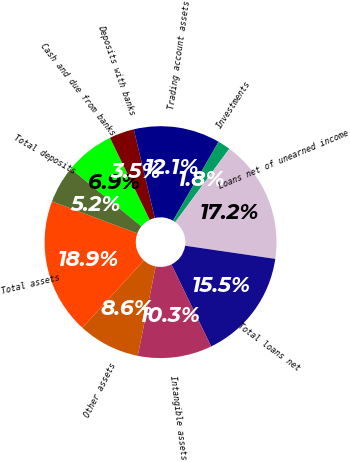Convert chart. <chart><loc_0><loc_0><loc_500><loc_500><pie_chart><fcel>Cash and due from banks<fcel>Deposits with banks<fcel>Trading account assets<fcel>Investments<fcel>Loans net of unearned income<fcel>Total loans net<fcel>Intangible assets<fcel>Other assets<fcel>Total assets<fcel>Total deposits<nl><fcel>6.91%<fcel>3.47%<fcel>12.06%<fcel>1.75%<fcel>17.21%<fcel>15.5%<fcel>10.34%<fcel>8.63%<fcel>18.93%<fcel>5.19%<nl></chart> 